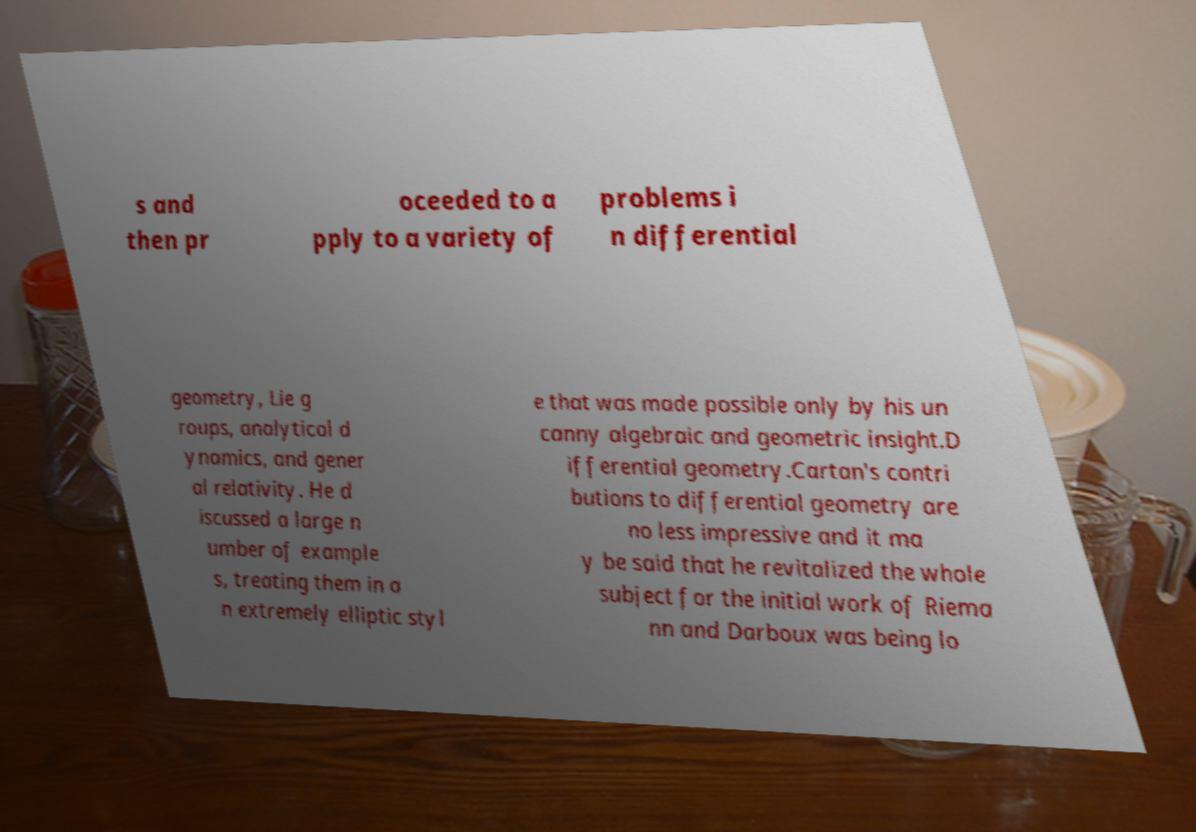Please read and relay the text visible in this image. What does it say? s and then pr oceeded to a pply to a variety of problems i n differential geometry, Lie g roups, analytical d ynamics, and gener al relativity. He d iscussed a large n umber of example s, treating them in a n extremely elliptic styl e that was made possible only by his un canny algebraic and geometric insight.D ifferential geometry.Cartan's contri butions to differential geometry are no less impressive and it ma y be said that he revitalized the whole subject for the initial work of Riema nn and Darboux was being lo 